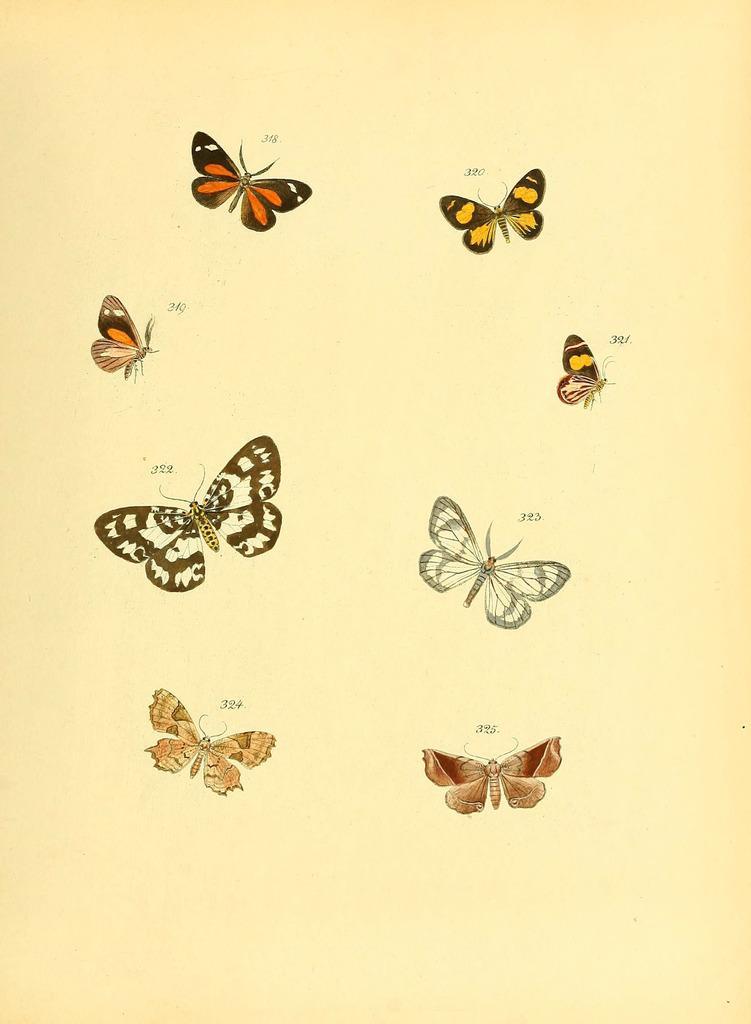Please provide a concise description of this image. This image consists of paper on which there are pictures of butterflies. 